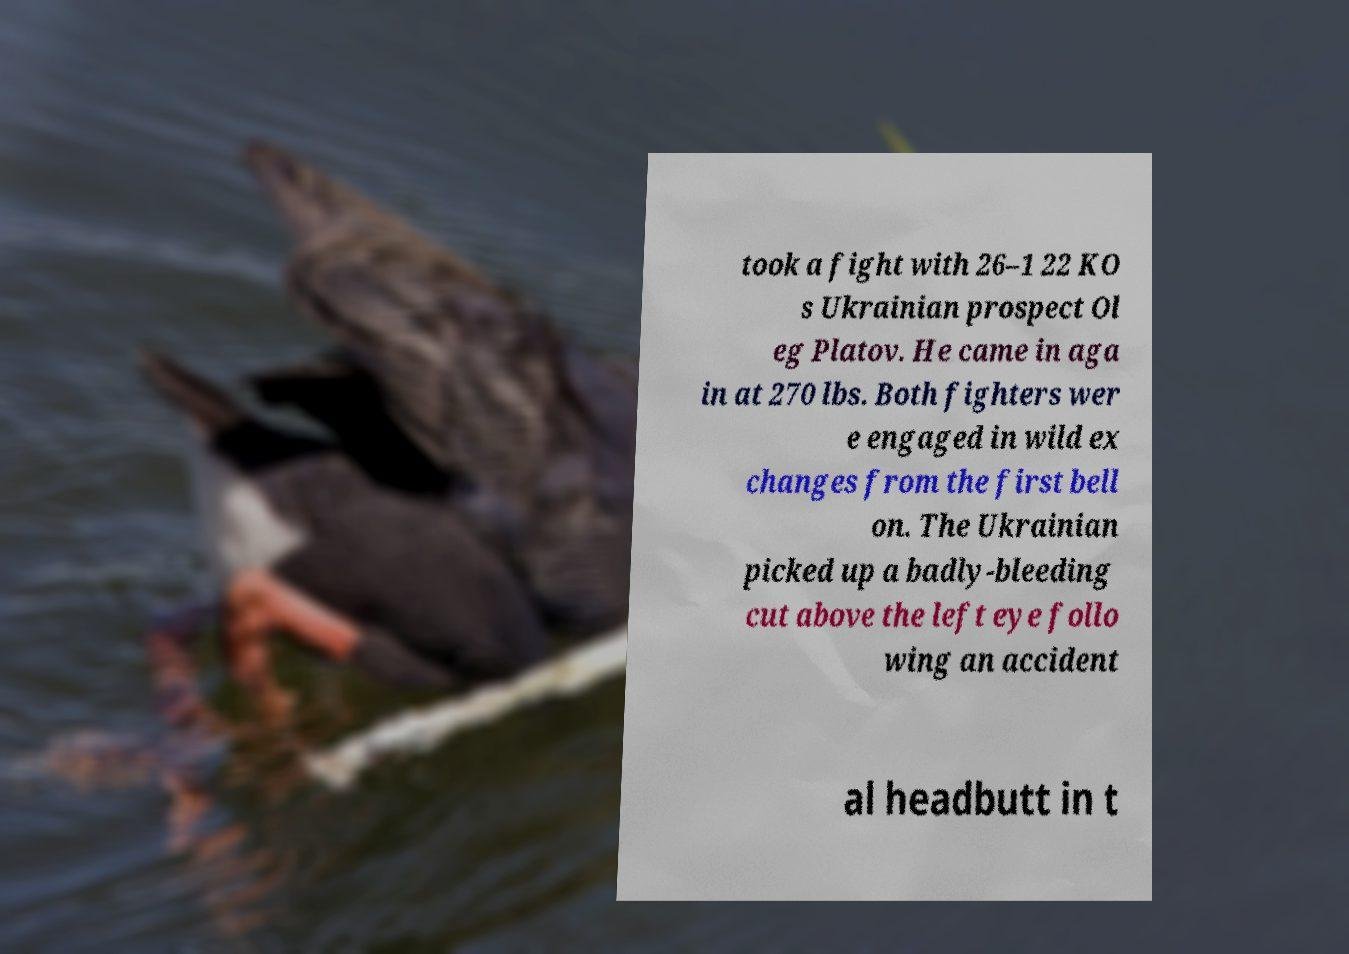Please read and relay the text visible in this image. What does it say? took a fight with 26–1 22 KO s Ukrainian prospect Ol eg Platov. He came in aga in at 270 lbs. Both fighters wer e engaged in wild ex changes from the first bell on. The Ukrainian picked up a badly-bleeding cut above the left eye follo wing an accident al headbutt in t 